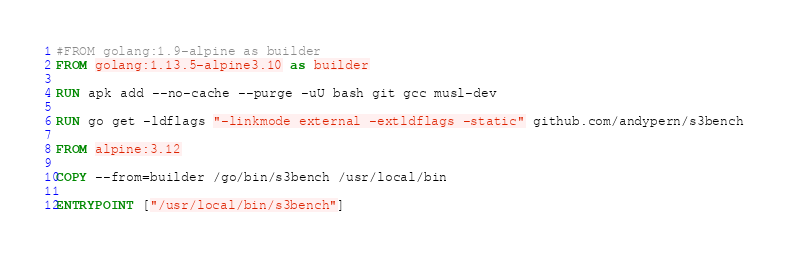<code> <loc_0><loc_0><loc_500><loc_500><_Dockerfile_>#FROM golang:1.9-alpine as builder
FROM golang:1.13.5-alpine3.10 as builder

RUN apk add --no-cache --purge -uU bash git gcc musl-dev

RUN go get -ldflags "-linkmode external -extldflags -static" github.com/andypern/s3bench

FROM alpine:3.12

COPY --from=builder /go/bin/s3bench /usr/local/bin 

ENTRYPOINT ["/usr/local/bin/s3bench"]
</code> 